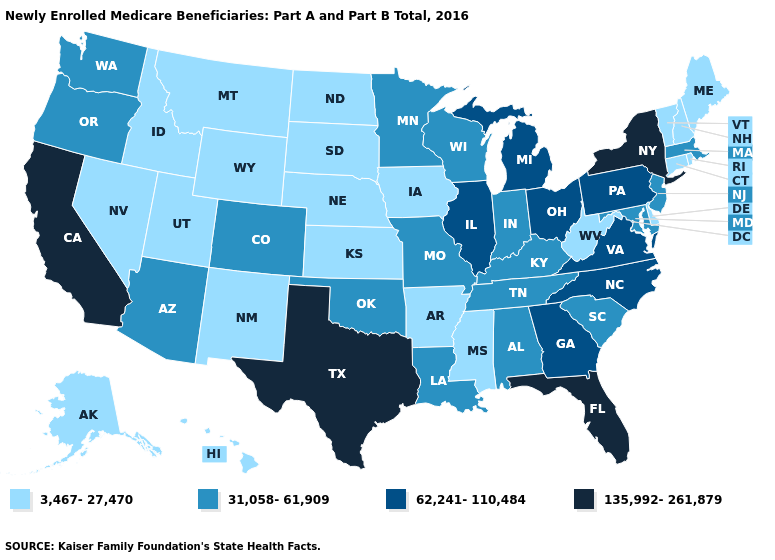What is the lowest value in the USA?
Keep it brief. 3,467-27,470. Name the states that have a value in the range 3,467-27,470?
Be succinct. Alaska, Arkansas, Connecticut, Delaware, Hawaii, Idaho, Iowa, Kansas, Maine, Mississippi, Montana, Nebraska, Nevada, New Hampshire, New Mexico, North Dakota, Rhode Island, South Dakota, Utah, Vermont, West Virginia, Wyoming. Does New York have the highest value in the USA?
Short answer required. Yes. What is the value of New Hampshire?
Quick response, please. 3,467-27,470. Does the first symbol in the legend represent the smallest category?
Short answer required. Yes. Does Virginia have the lowest value in the South?
Short answer required. No. Among the states that border Michigan , which have the highest value?
Give a very brief answer. Ohio. Name the states that have a value in the range 135,992-261,879?
Answer briefly. California, Florida, New York, Texas. What is the value of South Carolina?
Keep it brief. 31,058-61,909. What is the value of New York?
Write a very short answer. 135,992-261,879. Among the states that border New York , which have the lowest value?
Short answer required. Connecticut, Vermont. Name the states that have a value in the range 62,241-110,484?
Write a very short answer. Georgia, Illinois, Michigan, North Carolina, Ohio, Pennsylvania, Virginia. What is the value of Alaska?
Keep it brief. 3,467-27,470. Is the legend a continuous bar?
Short answer required. No. How many symbols are there in the legend?
Keep it brief. 4. 